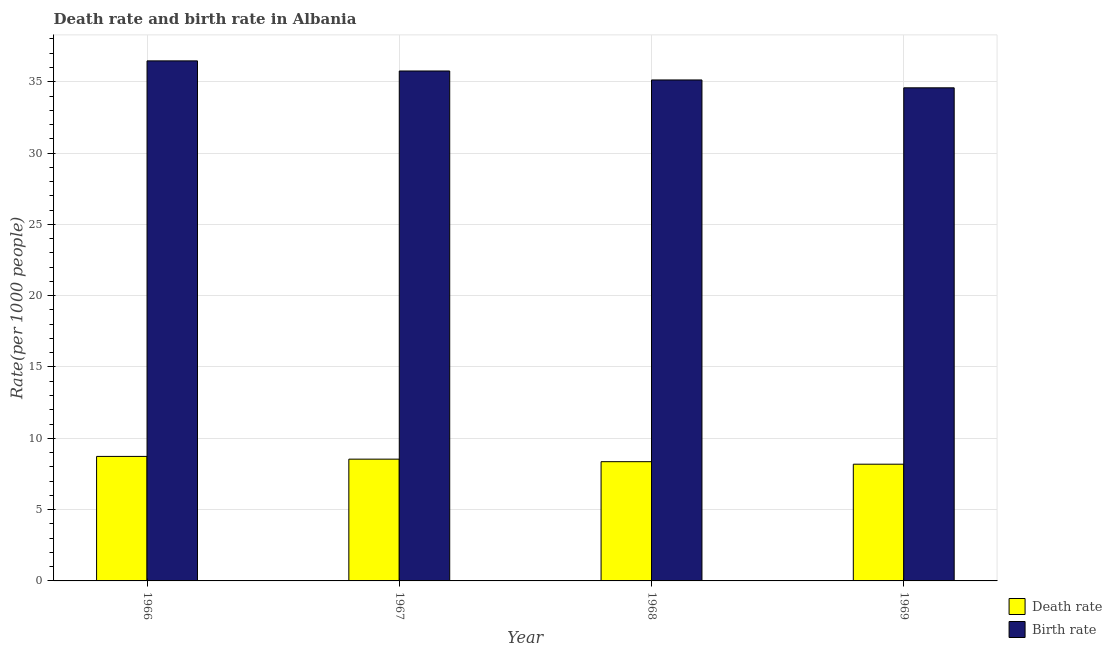Are the number of bars on each tick of the X-axis equal?
Your response must be concise. Yes. What is the label of the 3rd group of bars from the left?
Your response must be concise. 1968. In how many cases, is the number of bars for a given year not equal to the number of legend labels?
Ensure brevity in your answer.  0. What is the death rate in 1968?
Your response must be concise. 8.36. Across all years, what is the maximum birth rate?
Your answer should be very brief. 36.46. Across all years, what is the minimum birth rate?
Make the answer very short. 34.58. In which year was the death rate maximum?
Make the answer very short. 1966. In which year was the death rate minimum?
Provide a succinct answer. 1969. What is the total death rate in the graph?
Give a very brief answer. 33.81. What is the difference between the birth rate in 1967 and that in 1969?
Provide a succinct answer. 1.18. What is the difference between the birth rate in 1969 and the death rate in 1967?
Provide a succinct answer. -1.18. What is the average death rate per year?
Provide a succinct answer. 8.45. In the year 1966, what is the difference between the birth rate and death rate?
Your answer should be very brief. 0. What is the ratio of the birth rate in 1966 to that in 1967?
Give a very brief answer. 1.02. What is the difference between the highest and the second highest birth rate?
Provide a succinct answer. 0.71. What is the difference between the highest and the lowest death rate?
Your answer should be compact. 0.54. Is the sum of the birth rate in 1966 and 1969 greater than the maximum death rate across all years?
Your answer should be very brief. Yes. What does the 1st bar from the left in 1969 represents?
Your answer should be very brief. Death rate. What does the 1st bar from the right in 1969 represents?
Make the answer very short. Birth rate. How many bars are there?
Your answer should be compact. 8. Does the graph contain any zero values?
Provide a succinct answer. No. Does the graph contain grids?
Your answer should be compact. Yes. Where does the legend appear in the graph?
Keep it short and to the point. Bottom right. How many legend labels are there?
Make the answer very short. 2. What is the title of the graph?
Your answer should be compact. Death rate and birth rate in Albania. What is the label or title of the X-axis?
Make the answer very short. Year. What is the label or title of the Y-axis?
Provide a succinct answer. Rate(per 1000 people). What is the Rate(per 1000 people) in Death rate in 1966?
Provide a succinct answer. 8.73. What is the Rate(per 1000 people) in Birth rate in 1966?
Ensure brevity in your answer.  36.46. What is the Rate(per 1000 people) of Death rate in 1967?
Make the answer very short. 8.54. What is the Rate(per 1000 people) in Birth rate in 1967?
Offer a terse response. 35.76. What is the Rate(per 1000 people) in Death rate in 1968?
Ensure brevity in your answer.  8.36. What is the Rate(per 1000 people) of Birth rate in 1968?
Ensure brevity in your answer.  35.13. What is the Rate(per 1000 people) in Death rate in 1969?
Offer a terse response. 8.19. What is the Rate(per 1000 people) of Birth rate in 1969?
Make the answer very short. 34.58. Across all years, what is the maximum Rate(per 1000 people) in Death rate?
Provide a short and direct response. 8.73. Across all years, what is the maximum Rate(per 1000 people) of Birth rate?
Ensure brevity in your answer.  36.46. Across all years, what is the minimum Rate(per 1000 people) of Death rate?
Keep it short and to the point. 8.19. Across all years, what is the minimum Rate(per 1000 people) in Birth rate?
Give a very brief answer. 34.58. What is the total Rate(per 1000 people) in Death rate in the graph?
Provide a succinct answer. 33.81. What is the total Rate(per 1000 people) of Birth rate in the graph?
Your answer should be compact. 141.92. What is the difference between the Rate(per 1000 people) in Death rate in 1966 and that in 1967?
Give a very brief answer. 0.19. What is the difference between the Rate(per 1000 people) of Birth rate in 1966 and that in 1967?
Your response must be concise. 0.71. What is the difference between the Rate(per 1000 people) in Death rate in 1966 and that in 1968?
Provide a succinct answer. 0.37. What is the difference between the Rate(per 1000 people) in Birth rate in 1966 and that in 1968?
Provide a succinct answer. 1.34. What is the difference between the Rate(per 1000 people) in Death rate in 1966 and that in 1969?
Your answer should be very brief. 0.55. What is the difference between the Rate(per 1000 people) of Birth rate in 1966 and that in 1969?
Provide a short and direct response. 1.89. What is the difference between the Rate(per 1000 people) in Death rate in 1967 and that in 1968?
Provide a succinct answer. 0.18. What is the difference between the Rate(per 1000 people) in Birth rate in 1967 and that in 1968?
Provide a short and direct response. 0.63. What is the difference between the Rate(per 1000 people) of Death rate in 1967 and that in 1969?
Give a very brief answer. 0.35. What is the difference between the Rate(per 1000 people) of Birth rate in 1967 and that in 1969?
Ensure brevity in your answer.  1.18. What is the difference between the Rate(per 1000 people) in Death rate in 1968 and that in 1969?
Offer a terse response. 0.18. What is the difference between the Rate(per 1000 people) in Birth rate in 1968 and that in 1969?
Offer a terse response. 0.55. What is the difference between the Rate(per 1000 people) in Death rate in 1966 and the Rate(per 1000 people) in Birth rate in 1967?
Make the answer very short. -27.02. What is the difference between the Rate(per 1000 people) in Death rate in 1966 and the Rate(per 1000 people) in Birth rate in 1968?
Offer a terse response. -26.4. What is the difference between the Rate(per 1000 people) of Death rate in 1966 and the Rate(per 1000 people) of Birth rate in 1969?
Your answer should be very brief. -25.84. What is the difference between the Rate(per 1000 people) in Death rate in 1967 and the Rate(per 1000 people) in Birth rate in 1968?
Provide a succinct answer. -26.59. What is the difference between the Rate(per 1000 people) in Death rate in 1967 and the Rate(per 1000 people) in Birth rate in 1969?
Your answer should be compact. -26.04. What is the difference between the Rate(per 1000 people) of Death rate in 1968 and the Rate(per 1000 people) of Birth rate in 1969?
Your response must be concise. -26.21. What is the average Rate(per 1000 people) in Death rate per year?
Give a very brief answer. 8.45. What is the average Rate(per 1000 people) of Birth rate per year?
Make the answer very short. 35.48. In the year 1966, what is the difference between the Rate(per 1000 people) in Death rate and Rate(per 1000 people) in Birth rate?
Your answer should be compact. -27.73. In the year 1967, what is the difference between the Rate(per 1000 people) in Death rate and Rate(per 1000 people) in Birth rate?
Your answer should be very brief. -27.22. In the year 1968, what is the difference between the Rate(per 1000 people) of Death rate and Rate(per 1000 people) of Birth rate?
Your response must be concise. -26.77. In the year 1969, what is the difference between the Rate(per 1000 people) in Death rate and Rate(per 1000 people) in Birth rate?
Provide a short and direct response. -26.39. What is the ratio of the Rate(per 1000 people) of Death rate in 1966 to that in 1967?
Keep it short and to the point. 1.02. What is the ratio of the Rate(per 1000 people) in Birth rate in 1966 to that in 1967?
Your answer should be very brief. 1.02. What is the ratio of the Rate(per 1000 people) in Death rate in 1966 to that in 1968?
Provide a short and direct response. 1.04. What is the ratio of the Rate(per 1000 people) in Birth rate in 1966 to that in 1968?
Offer a terse response. 1.04. What is the ratio of the Rate(per 1000 people) in Death rate in 1966 to that in 1969?
Keep it short and to the point. 1.07. What is the ratio of the Rate(per 1000 people) of Birth rate in 1966 to that in 1969?
Make the answer very short. 1.05. What is the ratio of the Rate(per 1000 people) in Death rate in 1967 to that in 1968?
Ensure brevity in your answer.  1.02. What is the ratio of the Rate(per 1000 people) of Birth rate in 1967 to that in 1968?
Offer a very short reply. 1.02. What is the ratio of the Rate(per 1000 people) of Death rate in 1967 to that in 1969?
Make the answer very short. 1.04. What is the ratio of the Rate(per 1000 people) of Birth rate in 1967 to that in 1969?
Offer a very short reply. 1.03. What is the ratio of the Rate(per 1000 people) in Death rate in 1968 to that in 1969?
Your response must be concise. 1.02. What is the ratio of the Rate(per 1000 people) in Birth rate in 1968 to that in 1969?
Provide a succinct answer. 1.02. What is the difference between the highest and the second highest Rate(per 1000 people) in Death rate?
Provide a succinct answer. 0.19. What is the difference between the highest and the second highest Rate(per 1000 people) in Birth rate?
Your answer should be compact. 0.71. What is the difference between the highest and the lowest Rate(per 1000 people) of Death rate?
Provide a succinct answer. 0.55. What is the difference between the highest and the lowest Rate(per 1000 people) in Birth rate?
Keep it short and to the point. 1.89. 